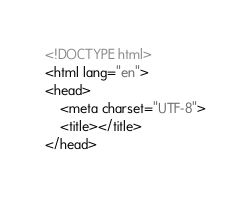<code> <loc_0><loc_0><loc_500><loc_500><_HTML_><!DOCTYPE html>
<html lang="en">
<head>
	<meta charset="UTF-8">
	<title></title>
</head></code> 